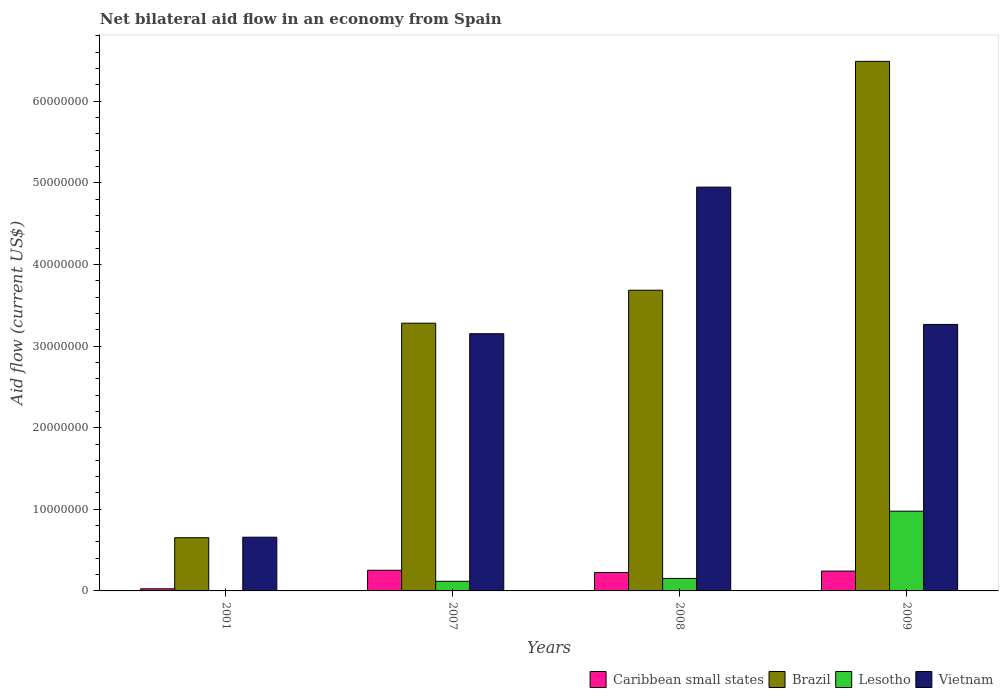How many different coloured bars are there?
Your response must be concise. 4. How many groups of bars are there?
Offer a very short reply. 4. Are the number of bars per tick equal to the number of legend labels?
Your answer should be compact. No. Are the number of bars on each tick of the X-axis equal?
Ensure brevity in your answer.  No. In how many cases, is the number of bars for a given year not equal to the number of legend labels?
Make the answer very short. 1. Across all years, what is the maximum net bilateral aid flow in Vietnam?
Your answer should be compact. 4.95e+07. Across all years, what is the minimum net bilateral aid flow in Brazil?
Offer a terse response. 6.52e+06. In which year was the net bilateral aid flow in Brazil maximum?
Ensure brevity in your answer.  2009. What is the total net bilateral aid flow in Brazil in the graph?
Ensure brevity in your answer.  1.41e+08. What is the difference between the net bilateral aid flow in Lesotho in 2007 and that in 2008?
Give a very brief answer. -3.50e+05. What is the difference between the net bilateral aid flow in Brazil in 2001 and the net bilateral aid flow in Lesotho in 2009?
Provide a short and direct response. -3.25e+06. What is the average net bilateral aid flow in Vietnam per year?
Your answer should be compact. 3.01e+07. In the year 2001, what is the difference between the net bilateral aid flow in Caribbean small states and net bilateral aid flow in Brazil?
Provide a succinct answer. -6.26e+06. In how many years, is the net bilateral aid flow in Caribbean small states greater than 64000000 US$?
Your answer should be compact. 0. What is the ratio of the net bilateral aid flow in Caribbean small states in 2001 to that in 2009?
Provide a succinct answer. 0.11. What is the difference between the highest and the second highest net bilateral aid flow in Vietnam?
Keep it short and to the point. 1.68e+07. What is the difference between the highest and the lowest net bilateral aid flow in Lesotho?
Offer a terse response. 9.77e+06. Is the sum of the net bilateral aid flow in Brazil in 2001 and 2009 greater than the maximum net bilateral aid flow in Lesotho across all years?
Make the answer very short. Yes. Is it the case that in every year, the sum of the net bilateral aid flow in Brazil and net bilateral aid flow in Caribbean small states is greater than the sum of net bilateral aid flow in Lesotho and net bilateral aid flow in Vietnam?
Make the answer very short. No. Is it the case that in every year, the sum of the net bilateral aid flow in Brazil and net bilateral aid flow in Caribbean small states is greater than the net bilateral aid flow in Vietnam?
Offer a terse response. No. Are all the bars in the graph horizontal?
Your response must be concise. No. What is the difference between two consecutive major ticks on the Y-axis?
Provide a short and direct response. 1.00e+07. Does the graph contain any zero values?
Your answer should be very brief. Yes. How many legend labels are there?
Keep it short and to the point. 4. How are the legend labels stacked?
Make the answer very short. Horizontal. What is the title of the graph?
Your response must be concise. Net bilateral aid flow in an economy from Spain. What is the label or title of the X-axis?
Offer a very short reply. Years. What is the label or title of the Y-axis?
Provide a succinct answer. Aid flow (current US$). What is the Aid flow (current US$) in Caribbean small states in 2001?
Your answer should be very brief. 2.60e+05. What is the Aid flow (current US$) of Brazil in 2001?
Provide a succinct answer. 6.52e+06. What is the Aid flow (current US$) in Lesotho in 2001?
Keep it short and to the point. 0. What is the Aid flow (current US$) in Vietnam in 2001?
Keep it short and to the point. 6.58e+06. What is the Aid flow (current US$) of Caribbean small states in 2007?
Ensure brevity in your answer.  2.53e+06. What is the Aid flow (current US$) in Brazil in 2007?
Your answer should be compact. 3.28e+07. What is the Aid flow (current US$) of Lesotho in 2007?
Give a very brief answer. 1.18e+06. What is the Aid flow (current US$) of Vietnam in 2007?
Your answer should be very brief. 3.15e+07. What is the Aid flow (current US$) in Caribbean small states in 2008?
Make the answer very short. 2.26e+06. What is the Aid flow (current US$) in Brazil in 2008?
Your response must be concise. 3.68e+07. What is the Aid flow (current US$) of Lesotho in 2008?
Keep it short and to the point. 1.53e+06. What is the Aid flow (current US$) of Vietnam in 2008?
Keep it short and to the point. 4.95e+07. What is the Aid flow (current US$) of Caribbean small states in 2009?
Keep it short and to the point. 2.43e+06. What is the Aid flow (current US$) in Brazil in 2009?
Your answer should be compact. 6.49e+07. What is the Aid flow (current US$) in Lesotho in 2009?
Your response must be concise. 9.77e+06. What is the Aid flow (current US$) of Vietnam in 2009?
Provide a succinct answer. 3.26e+07. Across all years, what is the maximum Aid flow (current US$) in Caribbean small states?
Offer a terse response. 2.53e+06. Across all years, what is the maximum Aid flow (current US$) in Brazil?
Keep it short and to the point. 6.49e+07. Across all years, what is the maximum Aid flow (current US$) of Lesotho?
Give a very brief answer. 9.77e+06. Across all years, what is the maximum Aid flow (current US$) in Vietnam?
Your answer should be very brief. 4.95e+07. Across all years, what is the minimum Aid flow (current US$) of Brazil?
Offer a very short reply. 6.52e+06. Across all years, what is the minimum Aid flow (current US$) of Vietnam?
Keep it short and to the point. 6.58e+06. What is the total Aid flow (current US$) in Caribbean small states in the graph?
Offer a terse response. 7.48e+06. What is the total Aid flow (current US$) of Brazil in the graph?
Offer a terse response. 1.41e+08. What is the total Aid flow (current US$) in Lesotho in the graph?
Give a very brief answer. 1.25e+07. What is the total Aid flow (current US$) of Vietnam in the graph?
Give a very brief answer. 1.20e+08. What is the difference between the Aid flow (current US$) in Caribbean small states in 2001 and that in 2007?
Your answer should be compact. -2.27e+06. What is the difference between the Aid flow (current US$) of Brazil in 2001 and that in 2007?
Provide a succinct answer. -2.63e+07. What is the difference between the Aid flow (current US$) in Vietnam in 2001 and that in 2007?
Ensure brevity in your answer.  -2.49e+07. What is the difference between the Aid flow (current US$) of Brazil in 2001 and that in 2008?
Make the answer very short. -3.03e+07. What is the difference between the Aid flow (current US$) in Vietnam in 2001 and that in 2008?
Your answer should be very brief. -4.29e+07. What is the difference between the Aid flow (current US$) in Caribbean small states in 2001 and that in 2009?
Provide a succinct answer. -2.17e+06. What is the difference between the Aid flow (current US$) of Brazil in 2001 and that in 2009?
Make the answer very short. -5.84e+07. What is the difference between the Aid flow (current US$) in Vietnam in 2001 and that in 2009?
Provide a succinct answer. -2.61e+07. What is the difference between the Aid flow (current US$) of Brazil in 2007 and that in 2008?
Give a very brief answer. -4.04e+06. What is the difference between the Aid flow (current US$) of Lesotho in 2007 and that in 2008?
Offer a very short reply. -3.50e+05. What is the difference between the Aid flow (current US$) in Vietnam in 2007 and that in 2008?
Provide a succinct answer. -1.80e+07. What is the difference between the Aid flow (current US$) in Brazil in 2007 and that in 2009?
Offer a very short reply. -3.21e+07. What is the difference between the Aid flow (current US$) in Lesotho in 2007 and that in 2009?
Provide a short and direct response. -8.59e+06. What is the difference between the Aid flow (current US$) in Vietnam in 2007 and that in 2009?
Give a very brief answer. -1.14e+06. What is the difference between the Aid flow (current US$) of Brazil in 2008 and that in 2009?
Offer a very short reply. -2.80e+07. What is the difference between the Aid flow (current US$) in Lesotho in 2008 and that in 2009?
Keep it short and to the point. -8.24e+06. What is the difference between the Aid flow (current US$) in Vietnam in 2008 and that in 2009?
Make the answer very short. 1.68e+07. What is the difference between the Aid flow (current US$) of Caribbean small states in 2001 and the Aid flow (current US$) of Brazil in 2007?
Your response must be concise. -3.25e+07. What is the difference between the Aid flow (current US$) in Caribbean small states in 2001 and the Aid flow (current US$) in Lesotho in 2007?
Your answer should be very brief. -9.20e+05. What is the difference between the Aid flow (current US$) in Caribbean small states in 2001 and the Aid flow (current US$) in Vietnam in 2007?
Your answer should be very brief. -3.12e+07. What is the difference between the Aid flow (current US$) of Brazil in 2001 and the Aid flow (current US$) of Lesotho in 2007?
Keep it short and to the point. 5.34e+06. What is the difference between the Aid flow (current US$) in Brazil in 2001 and the Aid flow (current US$) in Vietnam in 2007?
Make the answer very short. -2.50e+07. What is the difference between the Aid flow (current US$) in Caribbean small states in 2001 and the Aid flow (current US$) in Brazil in 2008?
Make the answer very short. -3.66e+07. What is the difference between the Aid flow (current US$) in Caribbean small states in 2001 and the Aid flow (current US$) in Lesotho in 2008?
Make the answer very short. -1.27e+06. What is the difference between the Aid flow (current US$) in Caribbean small states in 2001 and the Aid flow (current US$) in Vietnam in 2008?
Give a very brief answer. -4.92e+07. What is the difference between the Aid flow (current US$) of Brazil in 2001 and the Aid flow (current US$) of Lesotho in 2008?
Your answer should be very brief. 4.99e+06. What is the difference between the Aid flow (current US$) of Brazil in 2001 and the Aid flow (current US$) of Vietnam in 2008?
Your answer should be compact. -4.30e+07. What is the difference between the Aid flow (current US$) of Caribbean small states in 2001 and the Aid flow (current US$) of Brazil in 2009?
Give a very brief answer. -6.46e+07. What is the difference between the Aid flow (current US$) in Caribbean small states in 2001 and the Aid flow (current US$) in Lesotho in 2009?
Your response must be concise. -9.51e+06. What is the difference between the Aid flow (current US$) of Caribbean small states in 2001 and the Aid flow (current US$) of Vietnam in 2009?
Offer a very short reply. -3.24e+07. What is the difference between the Aid flow (current US$) in Brazil in 2001 and the Aid flow (current US$) in Lesotho in 2009?
Make the answer very short. -3.25e+06. What is the difference between the Aid flow (current US$) of Brazil in 2001 and the Aid flow (current US$) of Vietnam in 2009?
Offer a very short reply. -2.61e+07. What is the difference between the Aid flow (current US$) in Caribbean small states in 2007 and the Aid flow (current US$) in Brazil in 2008?
Your answer should be very brief. -3.43e+07. What is the difference between the Aid flow (current US$) of Caribbean small states in 2007 and the Aid flow (current US$) of Lesotho in 2008?
Your answer should be compact. 1.00e+06. What is the difference between the Aid flow (current US$) in Caribbean small states in 2007 and the Aid flow (current US$) in Vietnam in 2008?
Keep it short and to the point. -4.69e+07. What is the difference between the Aid flow (current US$) of Brazil in 2007 and the Aid flow (current US$) of Lesotho in 2008?
Keep it short and to the point. 3.13e+07. What is the difference between the Aid flow (current US$) in Brazil in 2007 and the Aid flow (current US$) in Vietnam in 2008?
Keep it short and to the point. -1.67e+07. What is the difference between the Aid flow (current US$) in Lesotho in 2007 and the Aid flow (current US$) in Vietnam in 2008?
Your answer should be compact. -4.83e+07. What is the difference between the Aid flow (current US$) in Caribbean small states in 2007 and the Aid flow (current US$) in Brazil in 2009?
Provide a succinct answer. -6.24e+07. What is the difference between the Aid flow (current US$) in Caribbean small states in 2007 and the Aid flow (current US$) in Lesotho in 2009?
Offer a very short reply. -7.24e+06. What is the difference between the Aid flow (current US$) in Caribbean small states in 2007 and the Aid flow (current US$) in Vietnam in 2009?
Make the answer very short. -3.01e+07. What is the difference between the Aid flow (current US$) of Brazil in 2007 and the Aid flow (current US$) of Lesotho in 2009?
Provide a short and direct response. 2.30e+07. What is the difference between the Aid flow (current US$) in Lesotho in 2007 and the Aid flow (current US$) in Vietnam in 2009?
Provide a short and direct response. -3.15e+07. What is the difference between the Aid flow (current US$) of Caribbean small states in 2008 and the Aid flow (current US$) of Brazil in 2009?
Your answer should be very brief. -6.26e+07. What is the difference between the Aid flow (current US$) of Caribbean small states in 2008 and the Aid flow (current US$) of Lesotho in 2009?
Your answer should be very brief. -7.51e+06. What is the difference between the Aid flow (current US$) in Caribbean small states in 2008 and the Aid flow (current US$) in Vietnam in 2009?
Your answer should be compact. -3.04e+07. What is the difference between the Aid flow (current US$) of Brazil in 2008 and the Aid flow (current US$) of Lesotho in 2009?
Keep it short and to the point. 2.71e+07. What is the difference between the Aid flow (current US$) of Brazil in 2008 and the Aid flow (current US$) of Vietnam in 2009?
Provide a succinct answer. 4.19e+06. What is the difference between the Aid flow (current US$) of Lesotho in 2008 and the Aid flow (current US$) of Vietnam in 2009?
Your response must be concise. -3.11e+07. What is the average Aid flow (current US$) of Caribbean small states per year?
Provide a succinct answer. 1.87e+06. What is the average Aid flow (current US$) in Brazil per year?
Ensure brevity in your answer.  3.53e+07. What is the average Aid flow (current US$) in Lesotho per year?
Your response must be concise. 3.12e+06. What is the average Aid flow (current US$) in Vietnam per year?
Provide a succinct answer. 3.01e+07. In the year 2001, what is the difference between the Aid flow (current US$) in Caribbean small states and Aid flow (current US$) in Brazil?
Ensure brevity in your answer.  -6.26e+06. In the year 2001, what is the difference between the Aid flow (current US$) of Caribbean small states and Aid flow (current US$) of Vietnam?
Offer a terse response. -6.32e+06. In the year 2007, what is the difference between the Aid flow (current US$) in Caribbean small states and Aid flow (current US$) in Brazil?
Offer a terse response. -3.03e+07. In the year 2007, what is the difference between the Aid flow (current US$) of Caribbean small states and Aid flow (current US$) of Lesotho?
Your answer should be very brief. 1.35e+06. In the year 2007, what is the difference between the Aid flow (current US$) of Caribbean small states and Aid flow (current US$) of Vietnam?
Make the answer very short. -2.90e+07. In the year 2007, what is the difference between the Aid flow (current US$) of Brazil and Aid flow (current US$) of Lesotho?
Keep it short and to the point. 3.16e+07. In the year 2007, what is the difference between the Aid flow (current US$) of Brazil and Aid flow (current US$) of Vietnam?
Your response must be concise. 1.29e+06. In the year 2007, what is the difference between the Aid flow (current US$) in Lesotho and Aid flow (current US$) in Vietnam?
Give a very brief answer. -3.03e+07. In the year 2008, what is the difference between the Aid flow (current US$) of Caribbean small states and Aid flow (current US$) of Brazil?
Provide a succinct answer. -3.46e+07. In the year 2008, what is the difference between the Aid flow (current US$) in Caribbean small states and Aid flow (current US$) in Lesotho?
Your answer should be compact. 7.30e+05. In the year 2008, what is the difference between the Aid flow (current US$) of Caribbean small states and Aid flow (current US$) of Vietnam?
Your answer should be compact. -4.72e+07. In the year 2008, what is the difference between the Aid flow (current US$) in Brazil and Aid flow (current US$) in Lesotho?
Your response must be concise. 3.53e+07. In the year 2008, what is the difference between the Aid flow (current US$) of Brazil and Aid flow (current US$) of Vietnam?
Offer a terse response. -1.26e+07. In the year 2008, what is the difference between the Aid flow (current US$) in Lesotho and Aid flow (current US$) in Vietnam?
Provide a succinct answer. -4.79e+07. In the year 2009, what is the difference between the Aid flow (current US$) in Caribbean small states and Aid flow (current US$) in Brazil?
Ensure brevity in your answer.  -6.24e+07. In the year 2009, what is the difference between the Aid flow (current US$) in Caribbean small states and Aid flow (current US$) in Lesotho?
Your answer should be compact. -7.34e+06. In the year 2009, what is the difference between the Aid flow (current US$) of Caribbean small states and Aid flow (current US$) of Vietnam?
Your response must be concise. -3.02e+07. In the year 2009, what is the difference between the Aid flow (current US$) of Brazil and Aid flow (current US$) of Lesotho?
Your answer should be compact. 5.51e+07. In the year 2009, what is the difference between the Aid flow (current US$) of Brazil and Aid flow (current US$) of Vietnam?
Make the answer very short. 3.22e+07. In the year 2009, what is the difference between the Aid flow (current US$) of Lesotho and Aid flow (current US$) of Vietnam?
Ensure brevity in your answer.  -2.29e+07. What is the ratio of the Aid flow (current US$) of Caribbean small states in 2001 to that in 2007?
Ensure brevity in your answer.  0.1. What is the ratio of the Aid flow (current US$) of Brazil in 2001 to that in 2007?
Give a very brief answer. 0.2. What is the ratio of the Aid flow (current US$) in Vietnam in 2001 to that in 2007?
Ensure brevity in your answer.  0.21. What is the ratio of the Aid flow (current US$) in Caribbean small states in 2001 to that in 2008?
Keep it short and to the point. 0.12. What is the ratio of the Aid flow (current US$) in Brazil in 2001 to that in 2008?
Provide a short and direct response. 0.18. What is the ratio of the Aid flow (current US$) in Vietnam in 2001 to that in 2008?
Offer a terse response. 0.13. What is the ratio of the Aid flow (current US$) in Caribbean small states in 2001 to that in 2009?
Your answer should be compact. 0.11. What is the ratio of the Aid flow (current US$) in Brazil in 2001 to that in 2009?
Your response must be concise. 0.1. What is the ratio of the Aid flow (current US$) in Vietnam in 2001 to that in 2009?
Provide a short and direct response. 0.2. What is the ratio of the Aid flow (current US$) of Caribbean small states in 2007 to that in 2008?
Keep it short and to the point. 1.12. What is the ratio of the Aid flow (current US$) of Brazil in 2007 to that in 2008?
Your answer should be very brief. 0.89. What is the ratio of the Aid flow (current US$) of Lesotho in 2007 to that in 2008?
Your answer should be very brief. 0.77. What is the ratio of the Aid flow (current US$) of Vietnam in 2007 to that in 2008?
Your answer should be very brief. 0.64. What is the ratio of the Aid flow (current US$) in Caribbean small states in 2007 to that in 2009?
Make the answer very short. 1.04. What is the ratio of the Aid flow (current US$) of Brazil in 2007 to that in 2009?
Give a very brief answer. 0.51. What is the ratio of the Aid flow (current US$) of Lesotho in 2007 to that in 2009?
Ensure brevity in your answer.  0.12. What is the ratio of the Aid flow (current US$) of Vietnam in 2007 to that in 2009?
Offer a terse response. 0.97. What is the ratio of the Aid flow (current US$) in Brazil in 2008 to that in 2009?
Offer a very short reply. 0.57. What is the ratio of the Aid flow (current US$) in Lesotho in 2008 to that in 2009?
Provide a succinct answer. 0.16. What is the ratio of the Aid flow (current US$) of Vietnam in 2008 to that in 2009?
Your answer should be very brief. 1.52. What is the difference between the highest and the second highest Aid flow (current US$) in Brazil?
Your answer should be compact. 2.80e+07. What is the difference between the highest and the second highest Aid flow (current US$) in Lesotho?
Offer a very short reply. 8.24e+06. What is the difference between the highest and the second highest Aid flow (current US$) of Vietnam?
Your response must be concise. 1.68e+07. What is the difference between the highest and the lowest Aid flow (current US$) in Caribbean small states?
Offer a terse response. 2.27e+06. What is the difference between the highest and the lowest Aid flow (current US$) of Brazil?
Your answer should be compact. 5.84e+07. What is the difference between the highest and the lowest Aid flow (current US$) of Lesotho?
Ensure brevity in your answer.  9.77e+06. What is the difference between the highest and the lowest Aid flow (current US$) in Vietnam?
Provide a short and direct response. 4.29e+07. 